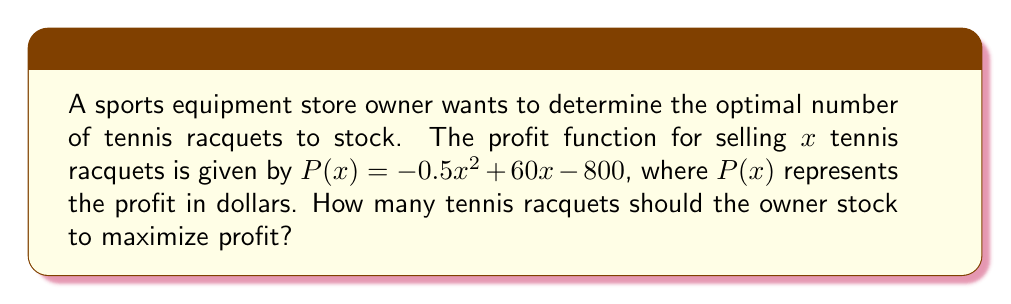Help me with this question. To find the optimal number of tennis racquets to stock, we need to find the maximum of the quadratic profit function.

Step 1: The profit function is a quadratic equation in the form $f(x) = ax^2 + bx + c$, where:
$a = -0.5$
$b = 60$
$c = -800$

Step 2: For a quadratic function, the maximum (or minimum) occurs at the vertex. The x-coordinate of the vertex is given by the formula $x = -\frac{b}{2a}$.

Step 3: Substitute the values:
$x = -\frac{60}{2(-0.5)} = -\frac{60}{-1} = 60$

Step 4: To confirm this is a maximum (not a minimum), note that $a < 0$, which means the parabola opens downward and has a maximum.

Step 5: Since we're dealing with inventory, we need to round to the nearest whole number. In this case, 60 is already a whole number.

Therefore, the optimal number of tennis racquets to stock is 60.
Answer: 60 racquets 